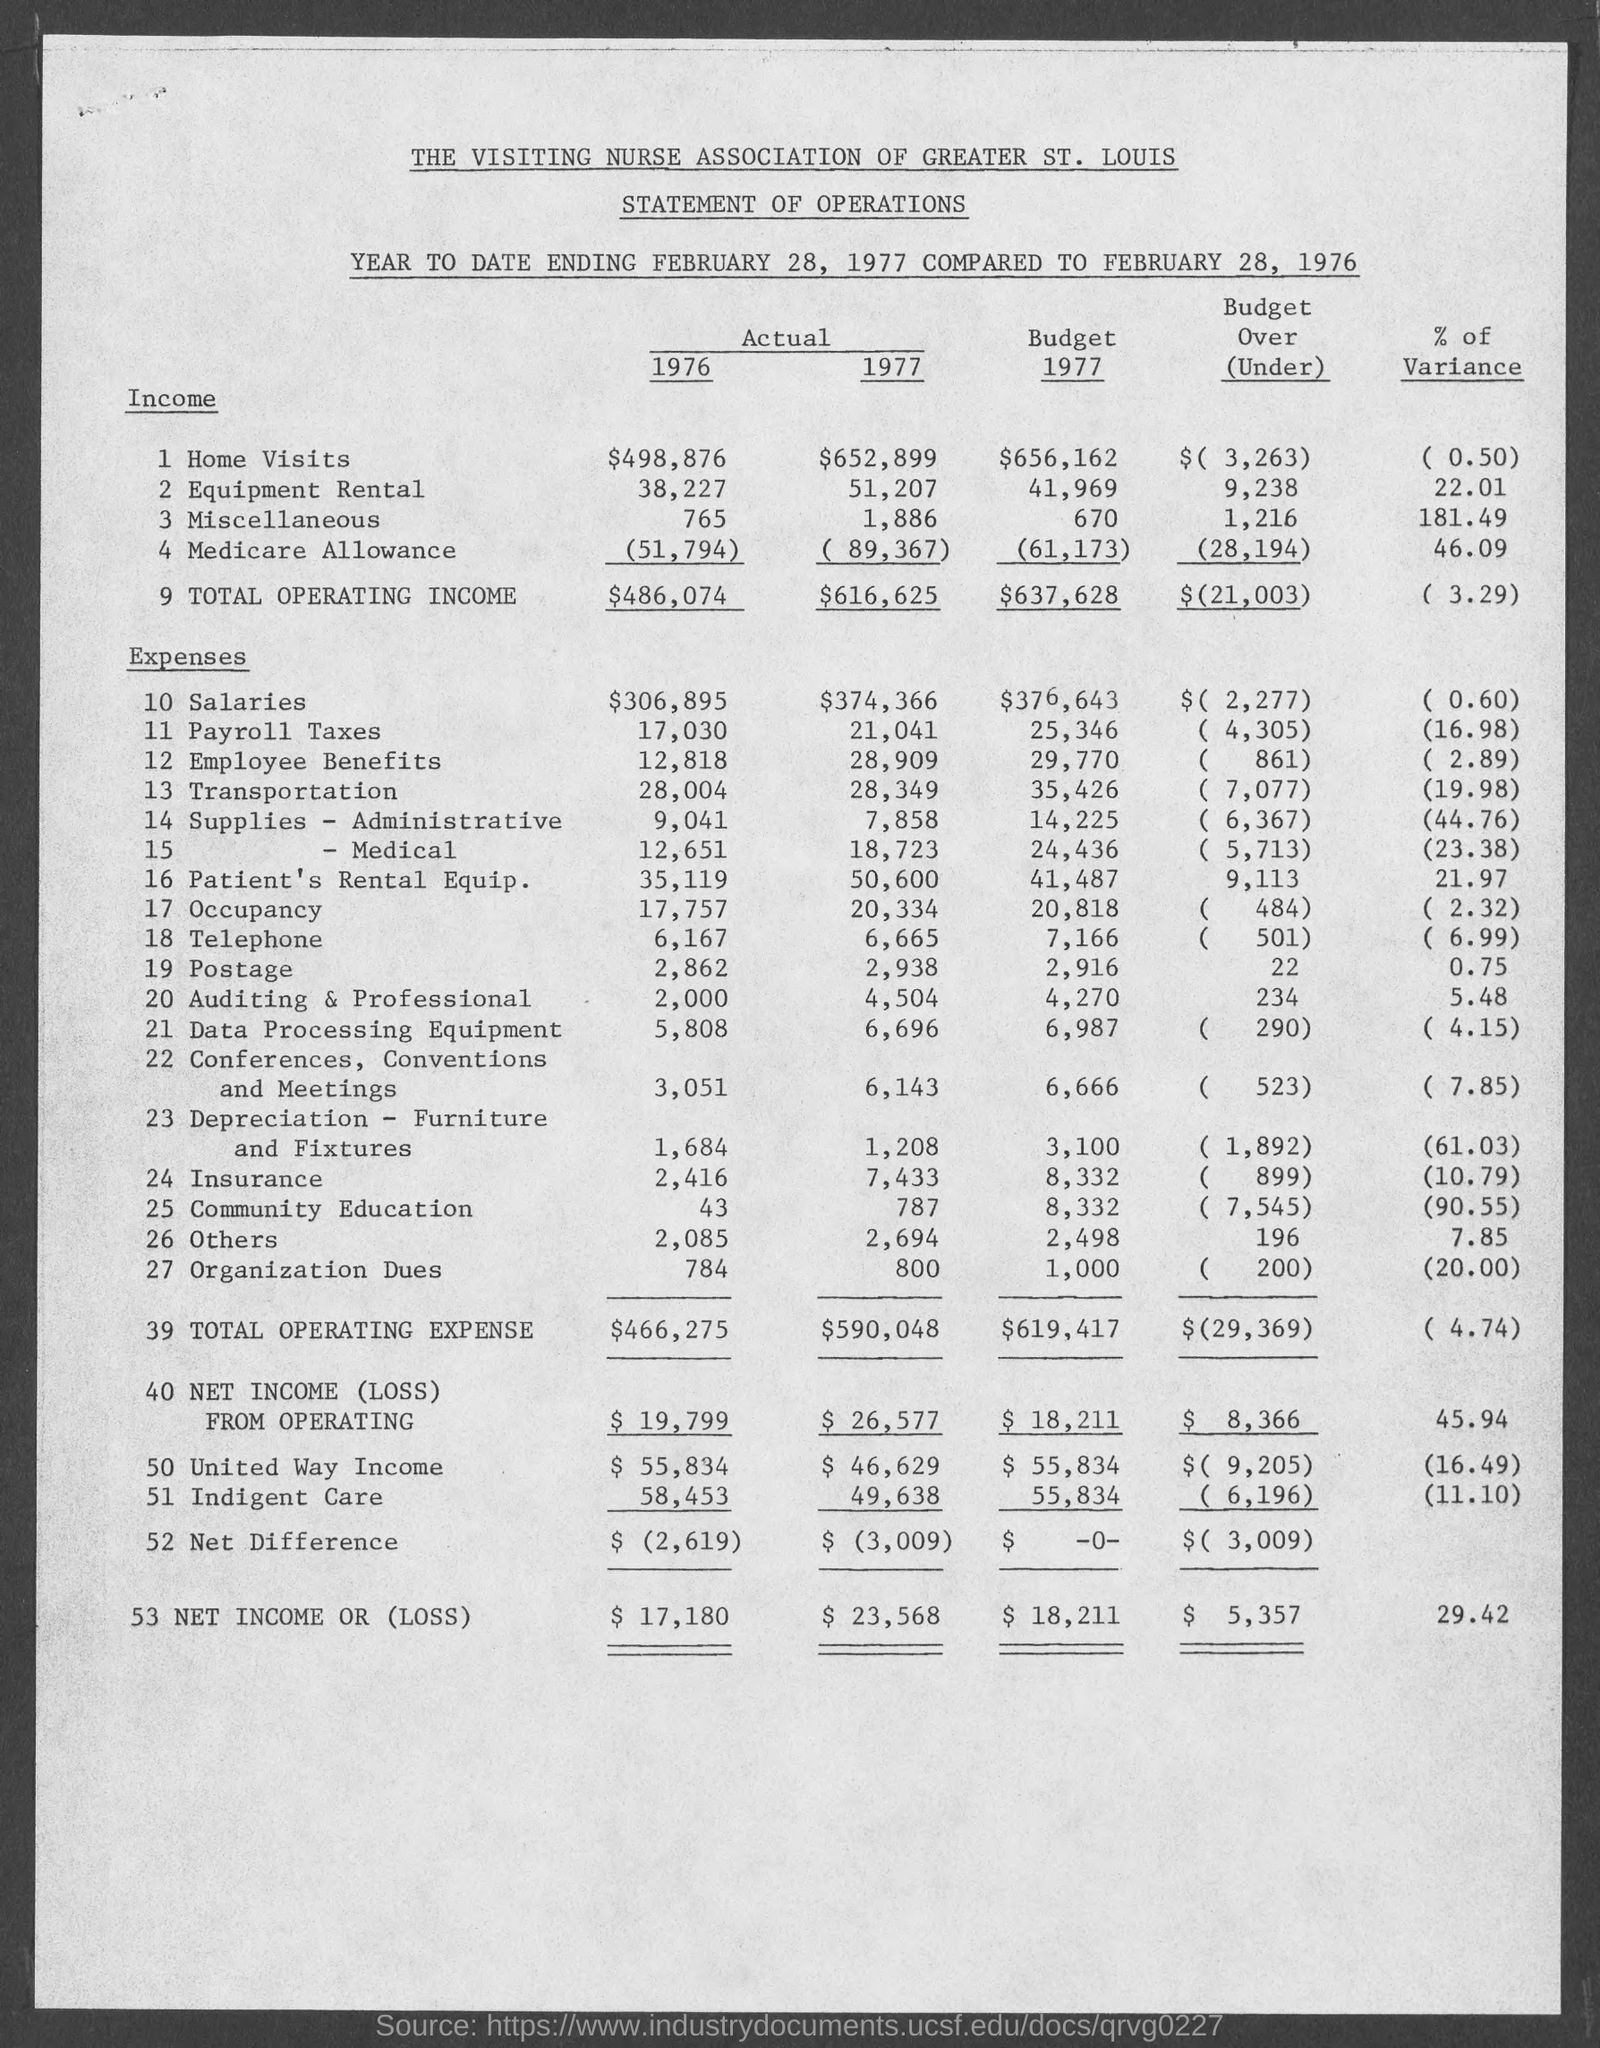What is the Actual Income for Home visits for 1976?
Make the answer very short. $498,876. What is the Actual Income for Home visits for 1977?
Offer a very short reply. $652,899. What is the Actual Income for Equipment Rental for 1976?
Your answer should be compact. 38,227. What is the Actual Income for Equipment Rental for 1977?
Your response must be concise. 51,207. What is the Actual Income for Miscellaneous for 1976?
Give a very brief answer. 765. What is the Actual Income for Miscellaneous for 1977?
Keep it short and to the point. 1,886. What is the Actual Income for Medicare Allowance for 1976?
Your answer should be very brief. (51,794). What is the Actual Income for Medicare Allowance for 1977?
Provide a succinct answer. ( 89,367). What is the Total Operating Income for 1976?
Your response must be concise. $486,074. 